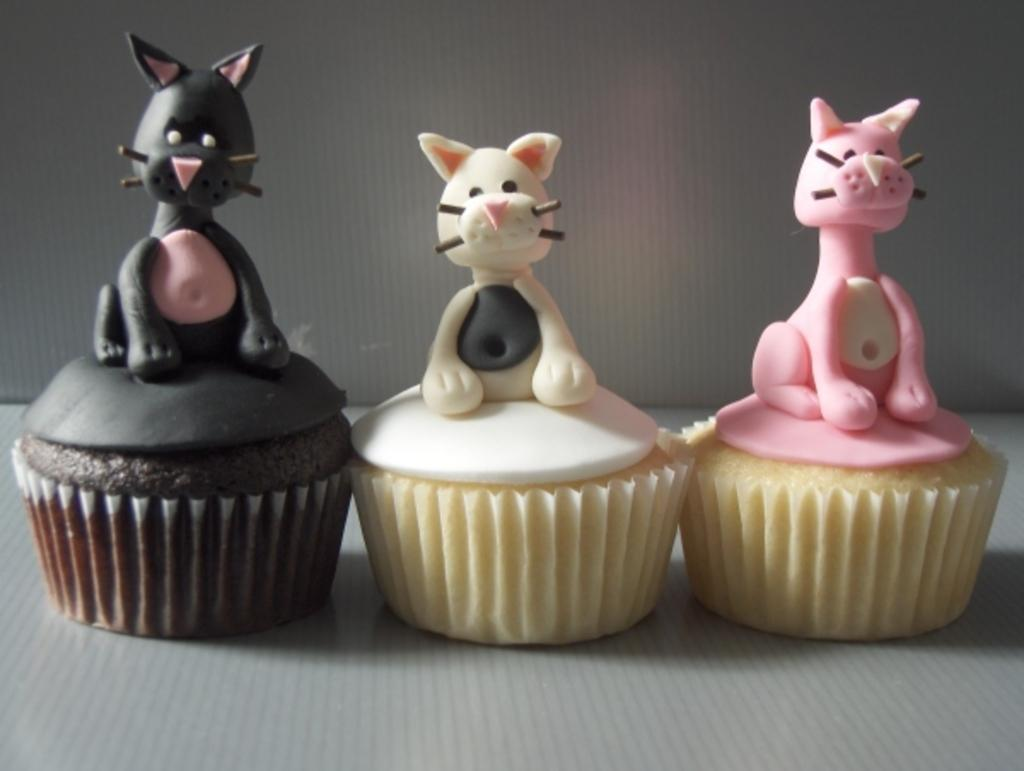What type of food is featured in the image? The image contains cupcakes. What decorations are on the cupcakes? There are structures of cats on the cupcakes. What can be observed about the cat structures? The cat structures are in different colors. Can you describe the possible surface beneath the cupcakes? There may be a table at the bottom of the image. How does the image convey a feeling of good-bye? The image does not convey a feeling of good-bye, as it features cupcakes with cat structures and does not contain any elements that suggest a farewell. 